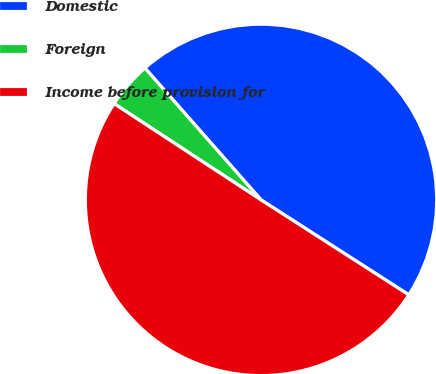Convert chart. <chart><loc_0><loc_0><loc_500><loc_500><pie_chart><fcel>Domestic<fcel>Foreign<fcel>Income before provision for<nl><fcel>45.58%<fcel>4.28%<fcel>50.14%<nl></chart> 